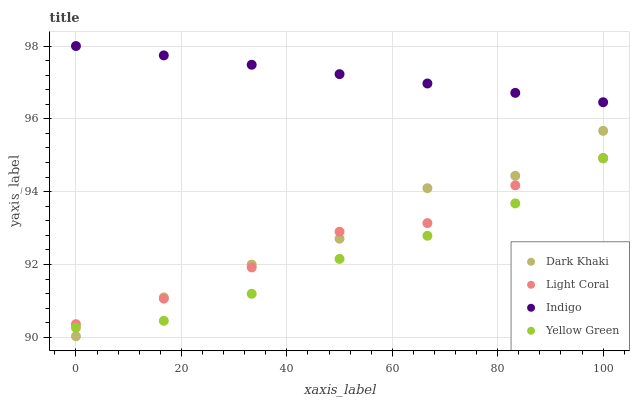Does Yellow Green have the minimum area under the curve?
Answer yes or no. Yes. Does Indigo have the maximum area under the curve?
Answer yes or no. Yes. Does Light Coral have the minimum area under the curve?
Answer yes or no. No. Does Light Coral have the maximum area under the curve?
Answer yes or no. No. Is Indigo the smoothest?
Answer yes or no. Yes. Is Dark Khaki the roughest?
Answer yes or no. Yes. Is Light Coral the smoothest?
Answer yes or no. No. Is Light Coral the roughest?
Answer yes or no. No. Does Dark Khaki have the lowest value?
Answer yes or no. Yes. Does Light Coral have the lowest value?
Answer yes or no. No. Does Indigo have the highest value?
Answer yes or no. Yes. Does Light Coral have the highest value?
Answer yes or no. No. Is Dark Khaki less than Indigo?
Answer yes or no. Yes. Is Indigo greater than Dark Khaki?
Answer yes or no. Yes. Does Light Coral intersect Dark Khaki?
Answer yes or no. Yes. Is Light Coral less than Dark Khaki?
Answer yes or no. No. Is Light Coral greater than Dark Khaki?
Answer yes or no. No. Does Dark Khaki intersect Indigo?
Answer yes or no. No. 